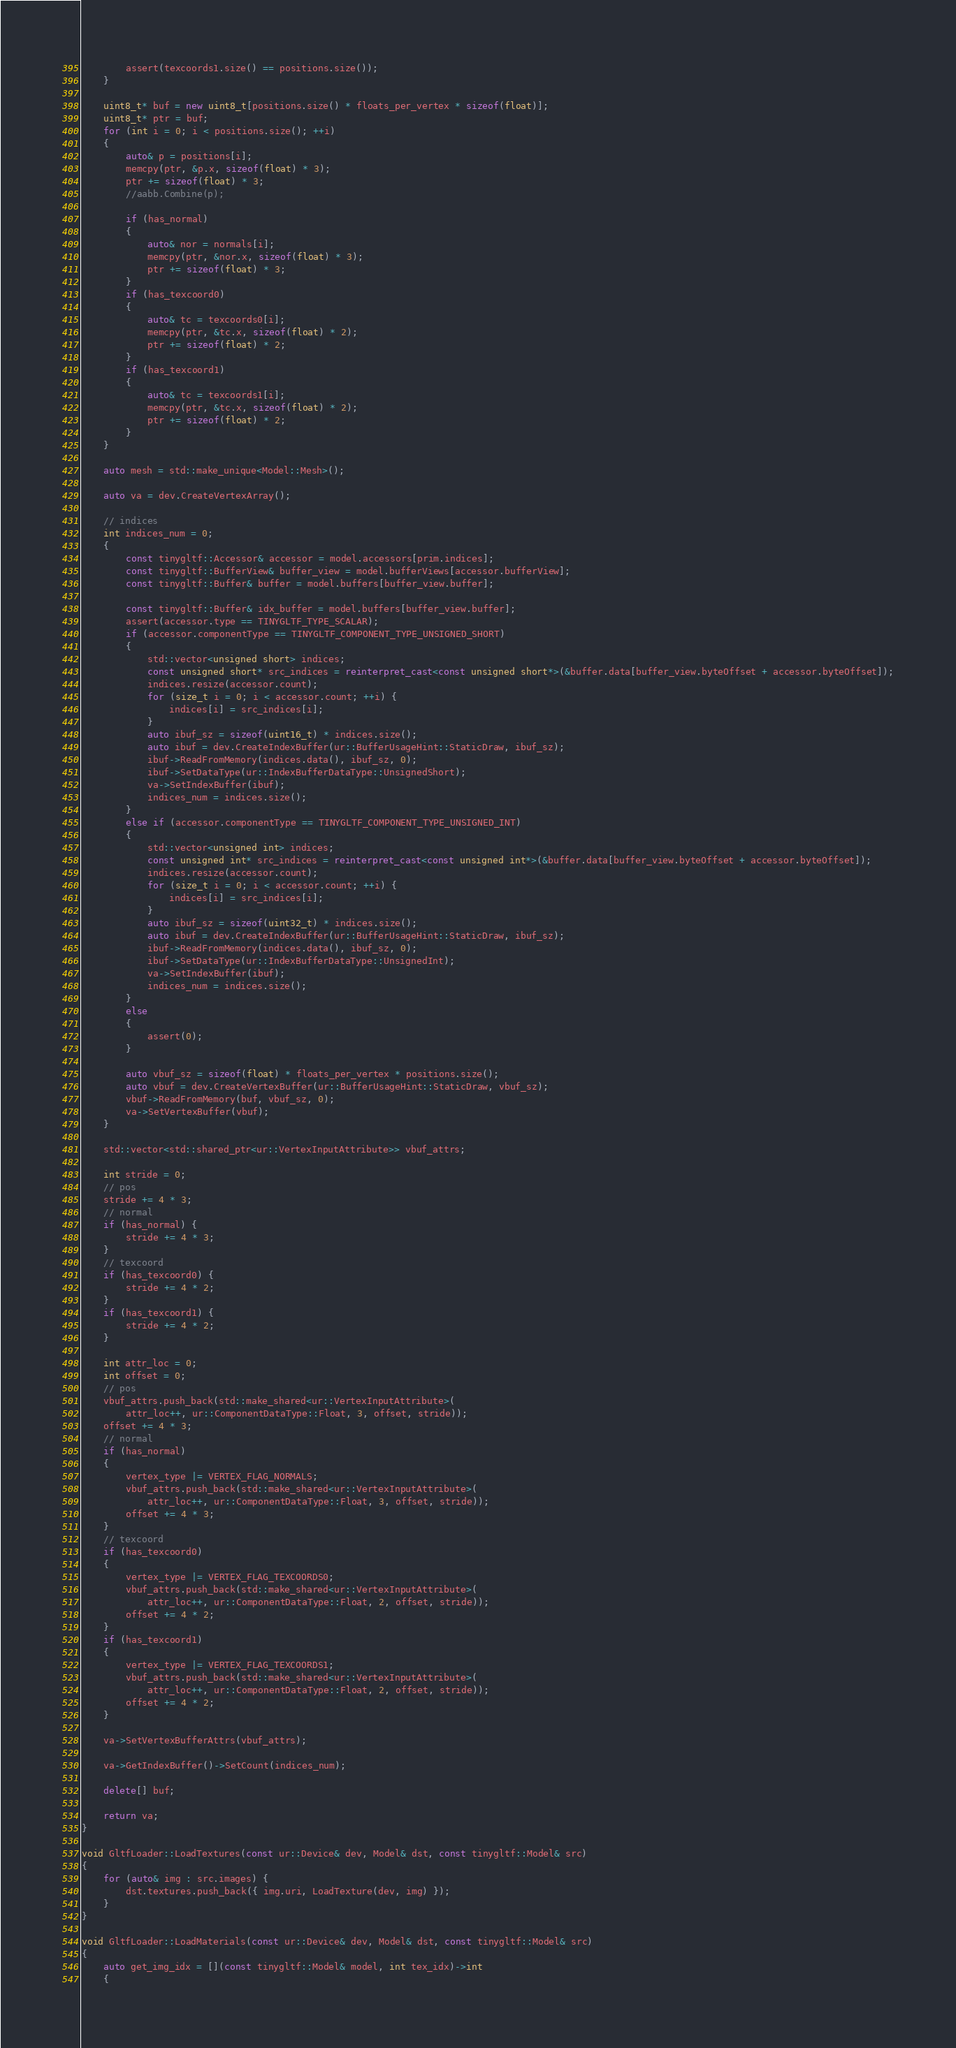Convert code to text. <code><loc_0><loc_0><loc_500><loc_500><_C++_>		assert(texcoords1.size() == positions.size());
	}

	uint8_t* buf = new uint8_t[positions.size() * floats_per_vertex * sizeof(float)];
	uint8_t* ptr = buf;
	for (int i = 0; i < positions.size(); ++i)
	{
		auto& p = positions[i];
		memcpy(ptr, &p.x, sizeof(float) * 3);
		ptr += sizeof(float) * 3;
		//aabb.Combine(p);

		if (has_normal)
		{
			auto& nor = normals[i];
			memcpy(ptr, &nor.x, sizeof(float) * 3);
			ptr += sizeof(float) * 3;
		}
		if (has_texcoord0)
		{
			auto& tc = texcoords0[i];
			memcpy(ptr, &tc.x, sizeof(float) * 2);
			ptr += sizeof(float) * 2;
		}
		if (has_texcoord1)
		{
			auto& tc = texcoords1[i];
			memcpy(ptr, &tc.x, sizeof(float) * 2);
			ptr += sizeof(float) * 2;
		}
	}

	auto mesh = std::make_unique<Model::Mesh>();

	auto va = dev.CreateVertexArray();

	// indices
	int indices_num = 0;
	{
		const tinygltf::Accessor& accessor = model.accessors[prim.indices];
		const tinygltf::BufferView& buffer_view = model.bufferViews[accessor.bufferView];
		const tinygltf::Buffer& buffer = model.buffers[buffer_view.buffer];

		const tinygltf::Buffer& idx_buffer = model.buffers[buffer_view.buffer];
		assert(accessor.type == TINYGLTF_TYPE_SCALAR);
		if (accessor.componentType == TINYGLTF_COMPONENT_TYPE_UNSIGNED_SHORT)
		{
			std::vector<unsigned short> indices;
			const unsigned short* src_indices = reinterpret_cast<const unsigned short*>(&buffer.data[buffer_view.byteOffset + accessor.byteOffset]);
			indices.resize(accessor.count);
			for (size_t i = 0; i < accessor.count; ++i) {
				indices[i] = src_indices[i];
			}
			auto ibuf_sz = sizeof(uint16_t) * indices.size();
			auto ibuf = dev.CreateIndexBuffer(ur::BufferUsageHint::StaticDraw, ibuf_sz);
			ibuf->ReadFromMemory(indices.data(), ibuf_sz, 0);
			ibuf->SetDataType(ur::IndexBufferDataType::UnsignedShort);
			va->SetIndexBuffer(ibuf);
			indices_num = indices.size();
		}
		else if (accessor.componentType == TINYGLTF_COMPONENT_TYPE_UNSIGNED_INT)
		{
			std::vector<unsigned int> indices;
			const unsigned int* src_indices = reinterpret_cast<const unsigned int*>(&buffer.data[buffer_view.byteOffset + accessor.byteOffset]);
			indices.resize(accessor.count);
			for (size_t i = 0; i < accessor.count; ++i) {
				indices[i] = src_indices[i];
			}
			auto ibuf_sz = sizeof(uint32_t) * indices.size();
			auto ibuf = dev.CreateIndexBuffer(ur::BufferUsageHint::StaticDraw, ibuf_sz);
			ibuf->ReadFromMemory(indices.data(), ibuf_sz, 0);
			ibuf->SetDataType(ur::IndexBufferDataType::UnsignedInt);
			va->SetIndexBuffer(ibuf);
			indices_num = indices.size();
		}
		else
		{
			assert(0);
		}

		auto vbuf_sz = sizeof(float) * floats_per_vertex * positions.size();
		auto vbuf = dev.CreateVertexBuffer(ur::BufferUsageHint::StaticDraw, vbuf_sz);
		vbuf->ReadFromMemory(buf, vbuf_sz, 0);
		va->SetVertexBuffer(vbuf);
	}

	std::vector<std::shared_ptr<ur::VertexInputAttribute>> vbuf_attrs;

	int stride = 0;
	// pos
	stride += 4 * 3;
	// normal
	if (has_normal) {
		stride += 4 * 3;
	}
	// texcoord
	if (has_texcoord0) {
		stride += 4 * 2;
	}
	if (has_texcoord1) {
		stride += 4 * 2;
	}

	int attr_loc = 0;
	int offset = 0;
	// pos
	vbuf_attrs.push_back(std::make_shared<ur::VertexInputAttribute>(
		attr_loc++, ur::ComponentDataType::Float, 3, offset, stride));
	offset += 4 * 3;
	// normal
	if (has_normal)
	{
		vertex_type |= VERTEX_FLAG_NORMALS;
		vbuf_attrs.push_back(std::make_shared<ur::VertexInputAttribute>(
			attr_loc++, ur::ComponentDataType::Float, 3, offset, stride));
		offset += 4 * 3;
	}
	// texcoord
	if (has_texcoord0)
	{
		vertex_type |= VERTEX_FLAG_TEXCOORDS0;
		vbuf_attrs.push_back(std::make_shared<ur::VertexInputAttribute>(
			attr_loc++, ur::ComponentDataType::Float, 2, offset, stride));
		offset += 4 * 2;
	}
	if (has_texcoord1)
	{
		vertex_type |= VERTEX_FLAG_TEXCOORDS1;
		vbuf_attrs.push_back(std::make_shared<ur::VertexInputAttribute>(
			attr_loc++, ur::ComponentDataType::Float, 2, offset, stride));
		offset += 4 * 2;
	}

	va->SetVertexBufferAttrs(vbuf_attrs);

	va->GetIndexBuffer()->SetCount(indices_num);

	delete[] buf;

	return va;
}

void GltfLoader::LoadTextures(const ur::Device& dev, Model& dst, const tinygltf::Model& src)
{
	for (auto& img : src.images) {
		dst.textures.push_back({ img.uri, LoadTexture(dev, img) });
	}
}

void GltfLoader::LoadMaterials(const ur::Device& dev, Model& dst, const tinygltf::Model& src)
{
	auto get_img_idx = [](const tinygltf::Model& model, int tex_idx)->int
	{</code> 